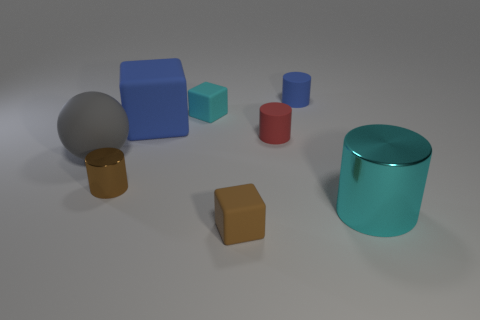There is a cylinder that is the same color as the large block; what is its size?
Keep it short and to the point. Small. There is a cyan thing that is behind the large gray matte thing; is it the same size as the cube in front of the cyan cylinder?
Provide a short and direct response. Yes. How big is the cyan thing that is behind the small red matte cylinder?
Your answer should be compact. Small. There is a tiny thing that is the same color as the small shiny cylinder; what is it made of?
Offer a very short reply. Rubber. What is the color of the metallic cylinder that is the same size as the red matte cylinder?
Provide a succinct answer. Brown. Do the brown rubber object and the red thing have the same size?
Your answer should be very brief. Yes. What size is the cylinder that is both behind the brown cylinder and in front of the large blue matte cube?
Offer a terse response. Small. What number of matte objects are yellow cubes or tiny cylinders?
Offer a very short reply. 2. Is the number of blue cylinders that are to the left of the small red cylinder greater than the number of large shiny cylinders?
Provide a short and direct response. No. What is the cyan object that is behind the big gray rubber thing made of?
Provide a succinct answer. Rubber. 